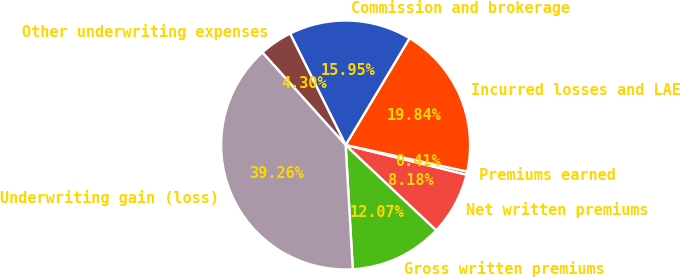<chart> <loc_0><loc_0><loc_500><loc_500><pie_chart><fcel>Gross written premiums<fcel>Net written premiums<fcel>Premiums earned<fcel>Incurred losses and LAE<fcel>Commission and brokerage<fcel>Other underwriting expenses<fcel>Underwriting gain (loss)<nl><fcel>12.07%<fcel>8.18%<fcel>0.41%<fcel>19.84%<fcel>15.95%<fcel>4.3%<fcel>39.26%<nl></chart> 